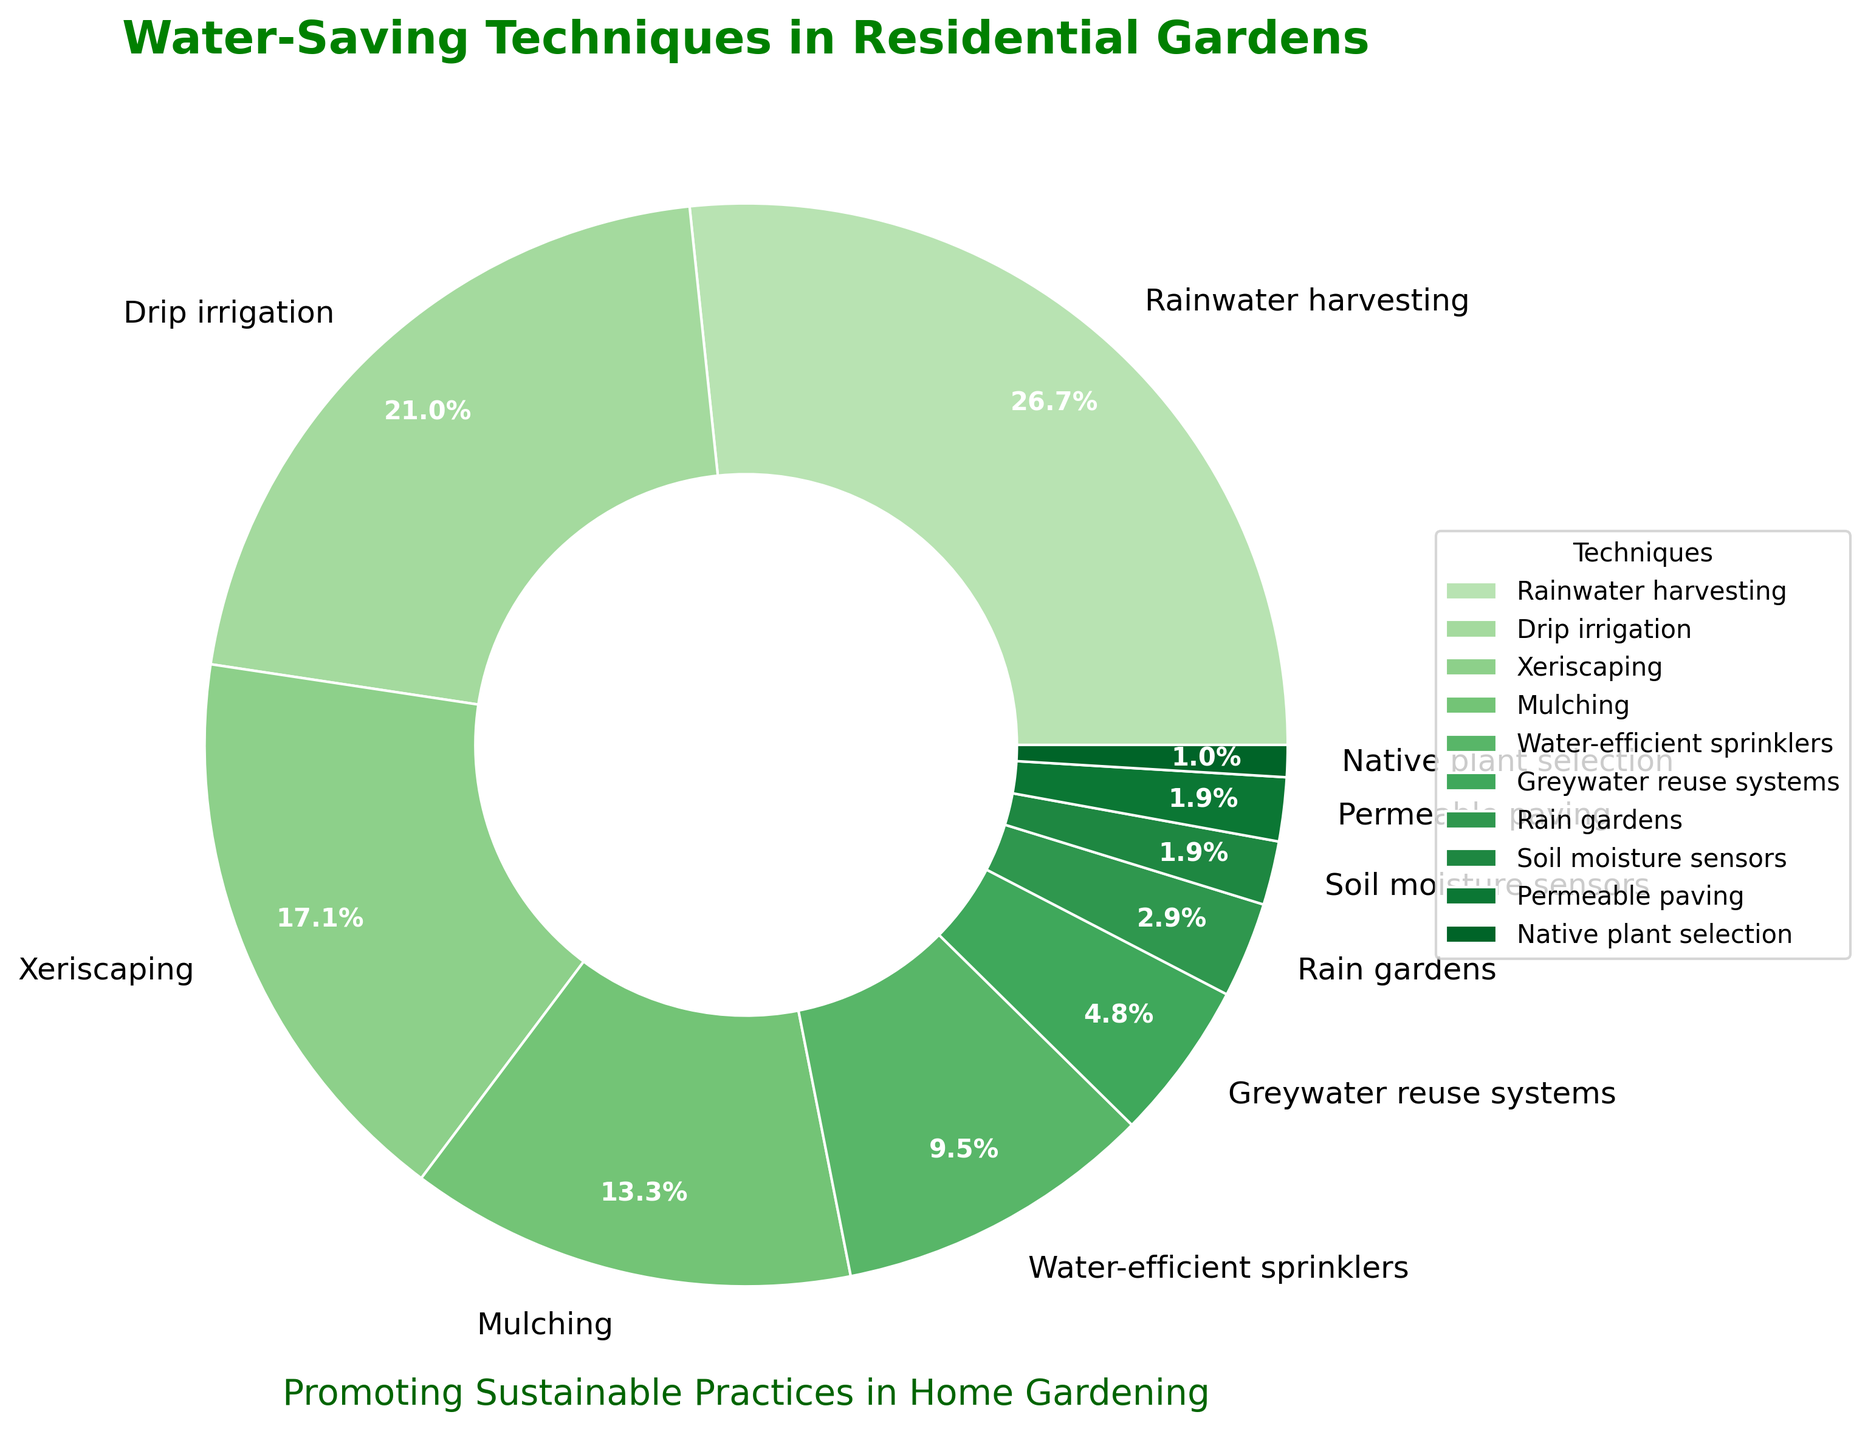What's the most common water-saving technique in residential gardens? The most common technique is the one with the highest percentage in the pie chart. We can see that Rainwater harvesting has the highest percentage at 28%.
Answer: Rainwater harvesting Which water-saving techniques make up more than 20% each? To find which techniques make up more than 20% each, we look at those with percentages greater than 20%. Rainwater harvesting (28%) and Drip irrigation (22%) both fit this criterion.
Answer: Rainwater harvesting and Drip irrigation What is the combined percentage of Xeriscaping and Mulching? The percentage of Xeriscaping is 18% and Mulching is 14%. By adding these two percentages together, we get 18% + 14% = 32%.
Answer: 32% Which technique has the least adoption in residential gardens? The technique with the least adoption is the one with the smallest slice in the pie chart. Here, Native plant selection has the smallest percentage, 1%.
Answer: Native plant selection Are there more gardens using Greywater reuse systems or Permeable paving? Comparing the percentages of Greywater reuse systems (5%) and Permeable paving (2%), we see that Greywater reuse systems are used more.
Answer: Greywater reuse systems What is the difference in percentage between Water-efficient sprinklers and Greywater reuse systems? The percentage for Water-efficient sprinklers is 10% and for Greywater reuse systems is 5%. The difference is 10% - 5% = 5%.
Answer: 5% How much higher is the percentage of Rain gardens compared to Soil moisture sensors? The percentage for Rain gardens is 3% and for Soil moisture sensors is 2%. The difference is 3% - 2% = 1%.
Answer: 1% What total percentage do the least adopted three techniques contribute? The three least adopted techniques are Native plant selection (1%), Permeable paving (2%), and Soil moisture sensors (2%). Adding these together, we get 1% + 2% + 2% = 5%.
Answer: 5% Which technique category is represented by the most dominant green shade in the chart? The most dominant green shade corresponds to the largest slice, which is Rainwater harvesting at 28%.
Answer: Rainwater harvesting Which technique has twice the adoption rate of Rain gardens? The percentage of Rain gardens is 3%. The technique with approximately twice this percentage is Greywater reuse systems at 5%. However, it's a bit more than double. The closer match mathematically would be Permeable paving or Soil moisture sensors with 2%, but they don't exactly fit the "twice" criteria.
Answer: Greywater reuse systems (approx.) 